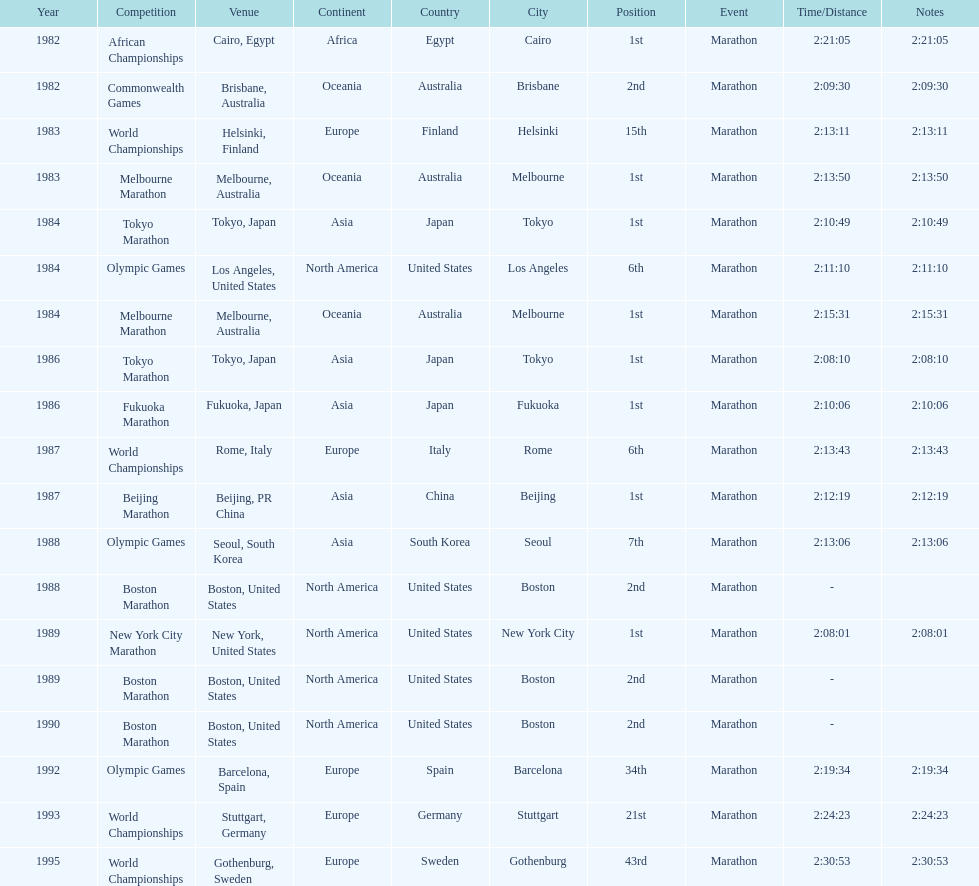What were the number of times the venue was located in the united states? 5. 